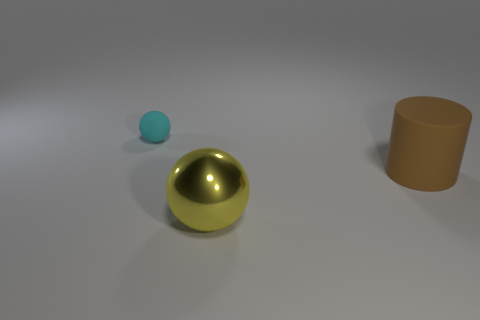Add 1 big spheres. How many objects exist? 4 Subtract all balls. How many objects are left? 1 Subtract 1 brown cylinders. How many objects are left? 2 Subtract all balls. Subtract all cylinders. How many objects are left? 0 Add 3 large yellow metallic balls. How many large yellow metallic balls are left? 4 Add 1 cyan matte balls. How many cyan matte balls exist? 2 